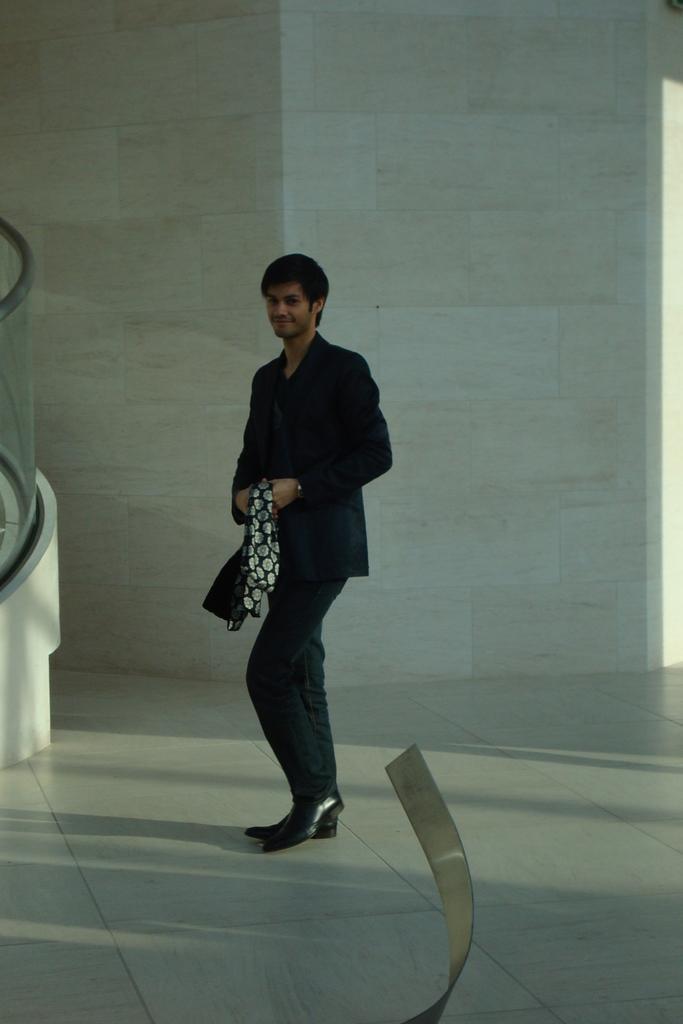Describe this image in one or two sentences. In this image I can see a person is standing and wearing black color dress and holding something. Back I can see the white color wall. 